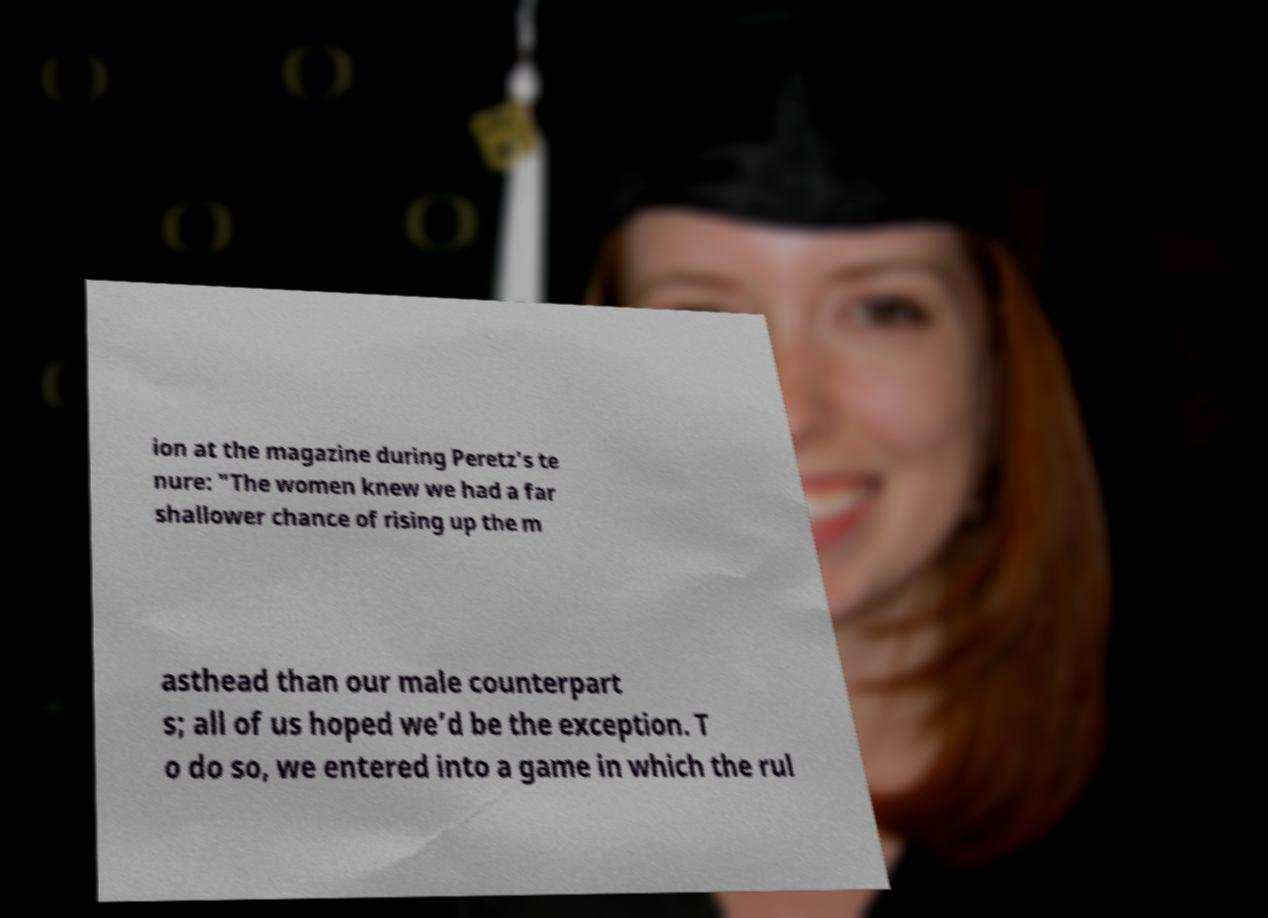Please identify and transcribe the text found in this image. ion at the magazine during Peretz's te nure: "The women knew we had a far shallower chance of rising up the m asthead than our male counterpart s; all of us hoped we’d be the exception. T o do so, we entered into a game in which the rul 